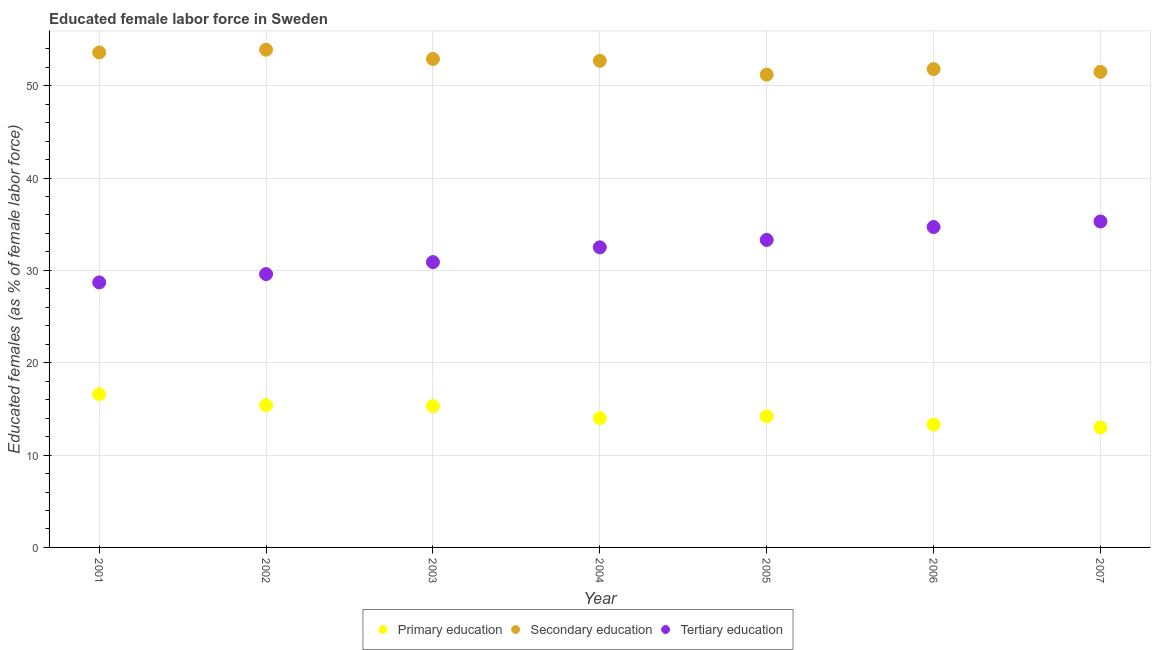How many different coloured dotlines are there?
Make the answer very short. 3. What is the percentage of female labor force who received primary education in 2001?
Your response must be concise. 16.6. Across all years, what is the maximum percentage of female labor force who received primary education?
Your response must be concise. 16.6. Across all years, what is the minimum percentage of female labor force who received secondary education?
Keep it short and to the point. 51.2. In which year was the percentage of female labor force who received tertiary education maximum?
Your answer should be compact. 2007. What is the total percentage of female labor force who received tertiary education in the graph?
Your answer should be very brief. 225. What is the difference between the percentage of female labor force who received secondary education in 2002 and that in 2005?
Give a very brief answer. 2.7. What is the difference between the percentage of female labor force who received tertiary education in 2006 and the percentage of female labor force who received primary education in 2004?
Your answer should be very brief. 20.7. What is the average percentage of female labor force who received secondary education per year?
Your answer should be very brief. 52.51. In the year 2007, what is the difference between the percentage of female labor force who received tertiary education and percentage of female labor force who received primary education?
Your answer should be very brief. 22.3. In how many years, is the percentage of female labor force who received primary education greater than 44 %?
Provide a succinct answer. 0. What is the ratio of the percentage of female labor force who received tertiary education in 2001 to that in 2004?
Ensure brevity in your answer.  0.88. What is the difference between the highest and the second highest percentage of female labor force who received secondary education?
Your answer should be compact. 0.3. What is the difference between the highest and the lowest percentage of female labor force who received secondary education?
Make the answer very short. 2.7. Is the sum of the percentage of female labor force who received primary education in 2002 and 2004 greater than the maximum percentage of female labor force who received secondary education across all years?
Your answer should be compact. No. Is the percentage of female labor force who received tertiary education strictly greater than the percentage of female labor force who received primary education over the years?
Give a very brief answer. Yes. How many dotlines are there?
Offer a terse response. 3. What is the difference between two consecutive major ticks on the Y-axis?
Your answer should be compact. 10. Does the graph contain any zero values?
Provide a short and direct response. No. Does the graph contain grids?
Give a very brief answer. Yes. Where does the legend appear in the graph?
Your answer should be very brief. Bottom center. What is the title of the graph?
Make the answer very short. Educated female labor force in Sweden. What is the label or title of the Y-axis?
Your response must be concise. Educated females (as % of female labor force). What is the Educated females (as % of female labor force) in Primary education in 2001?
Offer a very short reply. 16.6. What is the Educated females (as % of female labor force) of Secondary education in 2001?
Your answer should be compact. 53.6. What is the Educated females (as % of female labor force) in Tertiary education in 2001?
Give a very brief answer. 28.7. What is the Educated females (as % of female labor force) in Primary education in 2002?
Offer a very short reply. 15.4. What is the Educated females (as % of female labor force) of Secondary education in 2002?
Ensure brevity in your answer.  53.9. What is the Educated females (as % of female labor force) in Tertiary education in 2002?
Your response must be concise. 29.6. What is the Educated females (as % of female labor force) in Primary education in 2003?
Offer a very short reply. 15.3. What is the Educated females (as % of female labor force) in Secondary education in 2003?
Ensure brevity in your answer.  52.9. What is the Educated females (as % of female labor force) of Tertiary education in 2003?
Your answer should be very brief. 30.9. What is the Educated females (as % of female labor force) in Secondary education in 2004?
Keep it short and to the point. 52.7. What is the Educated females (as % of female labor force) in Tertiary education in 2004?
Ensure brevity in your answer.  32.5. What is the Educated females (as % of female labor force) of Primary education in 2005?
Your response must be concise. 14.2. What is the Educated females (as % of female labor force) of Secondary education in 2005?
Offer a very short reply. 51.2. What is the Educated females (as % of female labor force) in Tertiary education in 2005?
Ensure brevity in your answer.  33.3. What is the Educated females (as % of female labor force) in Primary education in 2006?
Make the answer very short. 13.3. What is the Educated females (as % of female labor force) in Secondary education in 2006?
Provide a succinct answer. 51.8. What is the Educated females (as % of female labor force) of Tertiary education in 2006?
Give a very brief answer. 34.7. What is the Educated females (as % of female labor force) of Primary education in 2007?
Keep it short and to the point. 13. What is the Educated females (as % of female labor force) in Secondary education in 2007?
Provide a succinct answer. 51.5. What is the Educated females (as % of female labor force) of Tertiary education in 2007?
Provide a succinct answer. 35.3. Across all years, what is the maximum Educated females (as % of female labor force) of Primary education?
Offer a very short reply. 16.6. Across all years, what is the maximum Educated females (as % of female labor force) in Secondary education?
Offer a terse response. 53.9. Across all years, what is the maximum Educated females (as % of female labor force) in Tertiary education?
Ensure brevity in your answer.  35.3. Across all years, what is the minimum Educated females (as % of female labor force) of Primary education?
Give a very brief answer. 13. Across all years, what is the minimum Educated females (as % of female labor force) in Secondary education?
Offer a terse response. 51.2. Across all years, what is the minimum Educated females (as % of female labor force) in Tertiary education?
Keep it short and to the point. 28.7. What is the total Educated females (as % of female labor force) in Primary education in the graph?
Offer a very short reply. 101.8. What is the total Educated females (as % of female labor force) in Secondary education in the graph?
Provide a short and direct response. 367.6. What is the total Educated females (as % of female labor force) of Tertiary education in the graph?
Your answer should be very brief. 225. What is the difference between the Educated females (as % of female labor force) in Primary education in 2001 and that in 2002?
Offer a very short reply. 1.2. What is the difference between the Educated females (as % of female labor force) of Tertiary education in 2001 and that in 2002?
Provide a succinct answer. -0.9. What is the difference between the Educated females (as % of female labor force) in Primary education in 2001 and that in 2003?
Offer a very short reply. 1.3. What is the difference between the Educated females (as % of female labor force) of Tertiary education in 2001 and that in 2003?
Keep it short and to the point. -2.2. What is the difference between the Educated females (as % of female labor force) of Primary education in 2001 and that in 2004?
Offer a terse response. 2.6. What is the difference between the Educated females (as % of female labor force) of Secondary education in 2001 and that in 2004?
Offer a very short reply. 0.9. What is the difference between the Educated females (as % of female labor force) in Tertiary education in 2001 and that in 2005?
Offer a very short reply. -4.6. What is the difference between the Educated females (as % of female labor force) of Primary education in 2001 and that in 2006?
Your response must be concise. 3.3. What is the difference between the Educated females (as % of female labor force) of Tertiary education in 2001 and that in 2007?
Your answer should be very brief. -6.6. What is the difference between the Educated females (as % of female labor force) of Primary education in 2002 and that in 2003?
Your answer should be very brief. 0.1. What is the difference between the Educated females (as % of female labor force) of Tertiary education in 2002 and that in 2003?
Provide a short and direct response. -1.3. What is the difference between the Educated females (as % of female labor force) in Primary education in 2002 and that in 2004?
Offer a terse response. 1.4. What is the difference between the Educated females (as % of female labor force) of Secondary education in 2002 and that in 2004?
Provide a short and direct response. 1.2. What is the difference between the Educated females (as % of female labor force) of Tertiary education in 2002 and that in 2004?
Your answer should be compact. -2.9. What is the difference between the Educated females (as % of female labor force) in Secondary education in 2002 and that in 2005?
Your answer should be compact. 2.7. What is the difference between the Educated females (as % of female labor force) of Tertiary education in 2002 and that in 2006?
Keep it short and to the point. -5.1. What is the difference between the Educated females (as % of female labor force) of Tertiary education in 2002 and that in 2007?
Provide a short and direct response. -5.7. What is the difference between the Educated females (as % of female labor force) of Primary education in 2003 and that in 2004?
Give a very brief answer. 1.3. What is the difference between the Educated females (as % of female labor force) of Secondary education in 2003 and that in 2004?
Keep it short and to the point. 0.2. What is the difference between the Educated females (as % of female labor force) of Tertiary education in 2003 and that in 2004?
Your answer should be very brief. -1.6. What is the difference between the Educated females (as % of female labor force) of Secondary education in 2003 and that in 2005?
Your response must be concise. 1.7. What is the difference between the Educated females (as % of female labor force) in Tertiary education in 2003 and that in 2005?
Offer a very short reply. -2.4. What is the difference between the Educated females (as % of female labor force) of Primary education in 2003 and that in 2006?
Your response must be concise. 2. What is the difference between the Educated females (as % of female labor force) in Secondary education in 2003 and that in 2006?
Give a very brief answer. 1.1. What is the difference between the Educated females (as % of female labor force) of Tertiary education in 2003 and that in 2006?
Keep it short and to the point. -3.8. What is the difference between the Educated females (as % of female labor force) of Tertiary education in 2004 and that in 2005?
Your answer should be very brief. -0.8. What is the difference between the Educated females (as % of female labor force) of Secondary education in 2004 and that in 2006?
Provide a succinct answer. 0.9. What is the difference between the Educated females (as % of female labor force) in Secondary education in 2004 and that in 2007?
Provide a succinct answer. 1.2. What is the difference between the Educated females (as % of female labor force) of Tertiary education in 2004 and that in 2007?
Provide a short and direct response. -2.8. What is the difference between the Educated females (as % of female labor force) of Primary education in 2005 and that in 2006?
Provide a succinct answer. 0.9. What is the difference between the Educated females (as % of female labor force) of Secondary education in 2005 and that in 2006?
Your answer should be compact. -0.6. What is the difference between the Educated females (as % of female labor force) of Primary education in 2005 and that in 2007?
Ensure brevity in your answer.  1.2. What is the difference between the Educated females (as % of female labor force) in Secondary education in 2005 and that in 2007?
Your answer should be compact. -0.3. What is the difference between the Educated females (as % of female labor force) of Tertiary education in 2005 and that in 2007?
Offer a very short reply. -2. What is the difference between the Educated females (as % of female labor force) in Primary education in 2001 and the Educated females (as % of female labor force) in Secondary education in 2002?
Offer a very short reply. -37.3. What is the difference between the Educated females (as % of female labor force) of Secondary education in 2001 and the Educated females (as % of female labor force) of Tertiary education in 2002?
Your answer should be very brief. 24. What is the difference between the Educated females (as % of female labor force) in Primary education in 2001 and the Educated females (as % of female labor force) in Secondary education in 2003?
Keep it short and to the point. -36.3. What is the difference between the Educated females (as % of female labor force) in Primary education in 2001 and the Educated females (as % of female labor force) in Tertiary education in 2003?
Offer a terse response. -14.3. What is the difference between the Educated females (as % of female labor force) in Secondary education in 2001 and the Educated females (as % of female labor force) in Tertiary education in 2003?
Offer a terse response. 22.7. What is the difference between the Educated females (as % of female labor force) of Primary education in 2001 and the Educated females (as % of female labor force) of Secondary education in 2004?
Offer a terse response. -36.1. What is the difference between the Educated females (as % of female labor force) in Primary education in 2001 and the Educated females (as % of female labor force) in Tertiary education in 2004?
Offer a terse response. -15.9. What is the difference between the Educated females (as % of female labor force) of Secondary education in 2001 and the Educated females (as % of female labor force) of Tertiary education in 2004?
Your answer should be compact. 21.1. What is the difference between the Educated females (as % of female labor force) of Primary education in 2001 and the Educated females (as % of female labor force) of Secondary education in 2005?
Your answer should be compact. -34.6. What is the difference between the Educated females (as % of female labor force) of Primary education in 2001 and the Educated females (as % of female labor force) of Tertiary education in 2005?
Your response must be concise. -16.7. What is the difference between the Educated females (as % of female labor force) in Secondary education in 2001 and the Educated females (as % of female labor force) in Tertiary education in 2005?
Give a very brief answer. 20.3. What is the difference between the Educated females (as % of female labor force) in Primary education in 2001 and the Educated females (as % of female labor force) in Secondary education in 2006?
Provide a short and direct response. -35.2. What is the difference between the Educated females (as % of female labor force) in Primary education in 2001 and the Educated females (as % of female labor force) in Tertiary education in 2006?
Your answer should be compact. -18.1. What is the difference between the Educated females (as % of female labor force) in Secondary education in 2001 and the Educated females (as % of female labor force) in Tertiary education in 2006?
Keep it short and to the point. 18.9. What is the difference between the Educated females (as % of female labor force) in Primary education in 2001 and the Educated females (as % of female labor force) in Secondary education in 2007?
Make the answer very short. -34.9. What is the difference between the Educated females (as % of female labor force) of Primary education in 2001 and the Educated females (as % of female labor force) of Tertiary education in 2007?
Ensure brevity in your answer.  -18.7. What is the difference between the Educated females (as % of female labor force) in Primary education in 2002 and the Educated females (as % of female labor force) in Secondary education in 2003?
Make the answer very short. -37.5. What is the difference between the Educated females (as % of female labor force) in Primary education in 2002 and the Educated females (as % of female labor force) in Tertiary education in 2003?
Keep it short and to the point. -15.5. What is the difference between the Educated females (as % of female labor force) of Primary education in 2002 and the Educated females (as % of female labor force) of Secondary education in 2004?
Offer a very short reply. -37.3. What is the difference between the Educated females (as % of female labor force) in Primary education in 2002 and the Educated females (as % of female labor force) in Tertiary education in 2004?
Provide a short and direct response. -17.1. What is the difference between the Educated females (as % of female labor force) of Secondary education in 2002 and the Educated females (as % of female labor force) of Tertiary education in 2004?
Make the answer very short. 21.4. What is the difference between the Educated females (as % of female labor force) in Primary education in 2002 and the Educated females (as % of female labor force) in Secondary education in 2005?
Make the answer very short. -35.8. What is the difference between the Educated females (as % of female labor force) of Primary education in 2002 and the Educated females (as % of female labor force) of Tertiary education in 2005?
Offer a very short reply. -17.9. What is the difference between the Educated females (as % of female labor force) in Secondary education in 2002 and the Educated females (as % of female labor force) in Tertiary education in 2005?
Provide a short and direct response. 20.6. What is the difference between the Educated females (as % of female labor force) in Primary education in 2002 and the Educated females (as % of female labor force) in Secondary education in 2006?
Your answer should be compact. -36.4. What is the difference between the Educated females (as % of female labor force) in Primary education in 2002 and the Educated females (as % of female labor force) in Tertiary education in 2006?
Your response must be concise. -19.3. What is the difference between the Educated females (as % of female labor force) in Secondary education in 2002 and the Educated females (as % of female labor force) in Tertiary education in 2006?
Provide a short and direct response. 19.2. What is the difference between the Educated females (as % of female labor force) in Primary education in 2002 and the Educated females (as % of female labor force) in Secondary education in 2007?
Ensure brevity in your answer.  -36.1. What is the difference between the Educated females (as % of female labor force) in Primary education in 2002 and the Educated females (as % of female labor force) in Tertiary education in 2007?
Your answer should be compact. -19.9. What is the difference between the Educated females (as % of female labor force) in Primary education in 2003 and the Educated females (as % of female labor force) in Secondary education in 2004?
Give a very brief answer. -37.4. What is the difference between the Educated females (as % of female labor force) in Primary education in 2003 and the Educated females (as % of female labor force) in Tertiary education in 2004?
Offer a terse response. -17.2. What is the difference between the Educated females (as % of female labor force) of Secondary education in 2003 and the Educated females (as % of female labor force) of Tertiary education in 2004?
Provide a succinct answer. 20.4. What is the difference between the Educated females (as % of female labor force) in Primary education in 2003 and the Educated females (as % of female labor force) in Secondary education in 2005?
Ensure brevity in your answer.  -35.9. What is the difference between the Educated females (as % of female labor force) in Primary education in 2003 and the Educated females (as % of female labor force) in Tertiary education in 2005?
Provide a short and direct response. -18. What is the difference between the Educated females (as % of female labor force) in Secondary education in 2003 and the Educated females (as % of female labor force) in Tertiary education in 2005?
Your response must be concise. 19.6. What is the difference between the Educated females (as % of female labor force) of Primary education in 2003 and the Educated females (as % of female labor force) of Secondary education in 2006?
Your answer should be compact. -36.5. What is the difference between the Educated females (as % of female labor force) in Primary education in 2003 and the Educated females (as % of female labor force) in Tertiary education in 2006?
Keep it short and to the point. -19.4. What is the difference between the Educated females (as % of female labor force) of Secondary education in 2003 and the Educated females (as % of female labor force) of Tertiary education in 2006?
Provide a short and direct response. 18.2. What is the difference between the Educated females (as % of female labor force) of Primary education in 2003 and the Educated females (as % of female labor force) of Secondary education in 2007?
Offer a very short reply. -36.2. What is the difference between the Educated females (as % of female labor force) of Primary education in 2003 and the Educated females (as % of female labor force) of Tertiary education in 2007?
Offer a terse response. -20. What is the difference between the Educated females (as % of female labor force) of Primary education in 2004 and the Educated females (as % of female labor force) of Secondary education in 2005?
Your response must be concise. -37.2. What is the difference between the Educated females (as % of female labor force) of Primary education in 2004 and the Educated females (as % of female labor force) of Tertiary education in 2005?
Your answer should be very brief. -19.3. What is the difference between the Educated females (as % of female labor force) of Primary education in 2004 and the Educated females (as % of female labor force) of Secondary education in 2006?
Provide a succinct answer. -37.8. What is the difference between the Educated females (as % of female labor force) in Primary education in 2004 and the Educated females (as % of female labor force) in Tertiary education in 2006?
Your answer should be compact. -20.7. What is the difference between the Educated females (as % of female labor force) of Secondary education in 2004 and the Educated females (as % of female labor force) of Tertiary education in 2006?
Keep it short and to the point. 18. What is the difference between the Educated females (as % of female labor force) of Primary education in 2004 and the Educated females (as % of female labor force) of Secondary education in 2007?
Provide a short and direct response. -37.5. What is the difference between the Educated females (as % of female labor force) of Primary education in 2004 and the Educated females (as % of female labor force) of Tertiary education in 2007?
Your response must be concise. -21.3. What is the difference between the Educated females (as % of female labor force) of Secondary education in 2004 and the Educated females (as % of female labor force) of Tertiary education in 2007?
Make the answer very short. 17.4. What is the difference between the Educated females (as % of female labor force) of Primary education in 2005 and the Educated females (as % of female labor force) of Secondary education in 2006?
Give a very brief answer. -37.6. What is the difference between the Educated females (as % of female labor force) of Primary education in 2005 and the Educated females (as % of female labor force) of Tertiary education in 2006?
Make the answer very short. -20.5. What is the difference between the Educated females (as % of female labor force) of Primary education in 2005 and the Educated females (as % of female labor force) of Secondary education in 2007?
Provide a short and direct response. -37.3. What is the difference between the Educated females (as % of female labor force) in Primary education in 2005 and the Educated females (as % of female labor force) in Tertiary education in 2007?
Keep it short and to the point. -21.1. What is the difference between the Educated females (as % of female labor force) in Secondary education in 2005 and the Educated females (as % of female labor force) in Tertiary education in 2007?
Your answer should be compact. 15.9. What is the difference between the Educated females (as % of female labor force) in Primary education in 2006 and the Educated females (as % of female labor force) in Secondary education in 2007?
Make the answer very short. -38.2. What is the average Educated females (as % of female labor force) of Primary education per year?
Your answer should be very brief. 14.54. What is the average Educated females (as % of female labor force) of Secondary education per year?
Provide a succinct answer. 52.51. What is the average Educated females (as % of female labor force) in Tertiary education per year?
Offer a terse response. 32.14. In the year 2001, what is the difference between the Educated females (as % of female labor force) of Primary education and Educated females (as % of female labor force) of Secondary education?
Keep it short and to the point. -37. In the year 2001, what is the difference between the Educated females (as % of female labor force) in Secondary education and Educated females (as % of female labor force) in Tertiary education?
Provide a succinct answer. 24.9. In the year 2002, what is the difference between the Educated females (as % of female labor force) of Primary education and Educated females (as % of female labor force) of Secondary education?
Offer a very short reply. -38.5. In the year 2002, what is the difference between the Educated females (as % of female labor force) of Secondary education and Educated females (as % of female labor force) of Tertiary education?
Provide a succinct answer. 24.3. In the year 2003, what is the difference between the Educated females (as % of female labor force) in Primary education and Educated females (as % of female labor force) in Secondary education?
Your answer should be compact. -37.6. In the year 2003, what is the difference between the Educated females (as % of female labor force) in Primary education and Educated females (as % of female labor force) in Tertiary education?
Make the answer very short. -15.6. In the year 2004, what is the difference between the Educated females (as % of female labor force) of Primary education and Educated females (as % of female labor force) of Secondary education?
Offer a terse response. -38.7. In the year 2004, what is the difference between the Educated females (as % of female labor force) in Primary education and Educated females (as % of female labor force) in Tertiary education?
Make the answer very short. -18.5. In the year 2004, what is the difference between the Educated females (as % of female labor force) in Secondary education and Educated females (as % of female labor force) in Tertiary education?
Make the answer very short. 20.2. In the year 2005, what is the difference between the Educated females (as % of female labor force) in Primary education and Educated females (as % of female labor force) in Secondary education?
Give a very brief answer. -37. In the year 2005, what is the difference between the Educated females (as % of female labor force) in Primary education and Educated females (as % of female labor force) in Tertiary education?
Make the answer very short. -19.1. In the year 2005, what is the difference between the Educated females (as % of female labor force) in Secondary education and Educated females (as % of female labor force) in Tertiary education?
Ensure brevity in your answer.  17.9. In the year 2006, what is the difference between the Educated females (as % of female labor force) of Primary education and Educated females (as % of female labor force) of Secondary education?
Give a very brief answer. -38.5. In the year 2006, what is the difference between the Educated females (as % of female labor force) of Primary education and Educated females (as % of female labor force) of Tertiary education?
Make the answer very short. -21.4. In the year 2006, what is the difference between the Educated females (as % of female labor force) in Secondary education and Educated females (as % of female labor force) in Tertiary education?
Provide a succinct answer. 17.1. In the year 2007, what is the difference between the Educated females (as % of female labor force) of Primary education and Educated females (as % of female labor force) of Secondary education?
Ensure brevity in your answer.  -38.5. In the year 2007, what is the difference between the Educated females (as % of female labor force) of Primary education and Educated females (as % of female labor force) of Tertiary education?
Offer a terse response. -22.3. What is the ratio of the Educated females (as % of female labor force) of Primary education in 2001 to that in 2002?
Give a very brief answer. 1.08. What is the ratio of the Educated females (as % of female labor force) of Tertiary education in 2001 to that in 2002?
Offer a very short reply. 0.97. What is the ratio of the Educated females (as % of female labor force) of Primary education in 2001 to that in 2003?
Make the answer very short. 1.08. What is the ratio of the Educated females (as % of female labor force) of Secondary education in 2001 to that in 2003?
Give a very brief answer. 1.01. What is the ratio of the Educated females (as % of female labor force) in Tertiary education in 2001 to that in 2003?
Your answer should be compact. 0.93. What is the ratio of the Educated females (as % of female labor force) in Primary education in 2001 to that in 2004?
Your response must be concise. 1.19. What is the ratio of the Educated females (as % of female labor force) of Secondary education in 2001 to that in 2004?
Your answer should be very brief. 1.02. What is the ratio of the Educated females (as % of female labor force) of Tertiary education in 2001 to that in 2004?
Make the answer very short. 0.88. What is the ratio of the Educated females (as % of female labor force) in Primary education in 2001 to that in 2005?
Offer a very short reply. 1.17. What is the ratio of the Educated females (as % of female labor force) of Secondary education in 2001 to that in 2005?
Your response must be concise. 1.05. What is the ratio of the Educated females (as % of female labor force) in Tertiary education in 2001 to that in 2005?
Offer a terse response. 0.86. What is the ratio of the Educated females (as % of female labor force) of Primary education in 2001 to that in 2006?
Provide a succinct answer. 1.25. What is the ratio of the Educated females (as % of female labor force) of Secondary education in 2001 to that in 2006?
Keep it short and to the point. 1.03. What is the ratio of the Educated females (as % of female labor force) of Tertiary education in 2001 to that in 2006?
Your answer should be compact. 0.83. What is the ratio of the Educated females (as % of female labor force) of Primary education in 2001 to that in 2007?
Provide a short and direct response. 1.28. What is the ratio of the Educated females (as % of female labor force) in Secondary education in 2001 to that in 2007?
Keep it short and to the point. 1.04. What is the ratio of the Educated females (as % of female labor force) in Tertiary education in 2001 to that in 2007?
Keep it short and to the point. 0.81. What is the ratio of the Educated females (as % of female labor force) in Primary education in 2002 to that in 2003?
Offer a terse response. 1.01. What is the ratio of the Educated females (as % of female labor force) of Secondary education in 2002 to that in 2003?
Your answer should be very brief. 1.02. What is the ratio of the Educated females (as % of female labor force) in Tertiary education in 2002 to that in 2003?
Offer a very short reply. 0.96. What is the ratio of the Educated females (as % of female labor force) of Secondary education in 2002 to that in 2004?
Your response must be concise. 1.02. What is the ratio of the Educated females (as % of female labor force) of Tertiary education in 2002 to that in 2004?
Make the answer very short. 0.91. What is the ratio of the Educated females (as % of female labor force) of Primary education in 2002 to that in 2005?
Give a very brief answer. 1.08. What is the ratio of the Educated females (as % of female labor force) of Secondary education in 2002 to that in 2005?
Provide a short and direct response. 1.05. What is the ratio of the Educated females (as % of female labor force) of Primary education in 2002 to that in 2006?
Offer a terse response. 1.16. What is the ratio of the Educated females (as % of female labor force) in Secondary education in 2002 to that in 2006?
Offer a terse response. 1.04. What is the ratio of the Educated females (as % of female labor force) in Tertiary education in 2002 to that in 2006?
Provide a short and direct response. 0.85. What is the ratio of the Educated females (as % of female labor force) of Primary education in 2002 to that in 2007?
Keep it short and to the point. 1.18. What is the ratio of the Educated females (as % of female labor force) in Secondary education in 2002 to that in 2007?
Your answer should be compact. 1.05. What is the ratio of the Educated females (as % of female labor force) in Tertiary education in 2002 to that in 2007?
Offer a terse response. 0.84. What is the ratio of the Educated females (as % of female labor force) of Primary education in 2003 to that in 2004?
Give a very brief answer. 1.09. What is the ratio of the Educated females (as % of female labor force) of Secondary education in 2003 to that in 2004?
Your response must be concise. 1. What is the ratio of the Educated females (as % of female labor force) of Tertiary education in 2003 to that in 2004?
Your answer should be very brief. 0.95. What is the ratio of the Educated females (as % of female labor force) of Primary education in 2003 to that in 2005?
Your answer should be very brief. 1.08. What is the ratio of the Educated females (as % of female labor force) of Secondary education in 2003 to that in 2005?
Your answer should be compact. 1.03. What is the ratio of the Educated females (as % of female labor force) of Tertiary education in 2003 to that in 2005?
Offer a terse response. 0.93. What is the ratio of the Educated females (as % of female labor force) of Primary education in 2003 to that in 2006?
Your response must be concise. 1.15. What is the ratio of the Educated females (as % of female labor force) in Secondary education in 2003 to that in 2006?
Provide a short and direct response. 1.02. What is the ratio of the Educated females (as % of female labor force) in Tertiary education in 2003 to that in 2006?
Your answer should be compact. 0.89. What is the ratio of the Educated females (as % of female labor force) of Primary education in 2003 to that in 2007?
Provide a short and direct response. 1.18. What is the ratio of the Educated females (as % of female labor force) of Secondary education in 2003 to that in 2007?
Provide a succinct answer. 1.03. What is the ratio of the Educated females (as % of female labor force) in Tertiary education in 2003 to that in 2007?
Provide a short and direct response. 0.88. What is the ratio of the Educated females (as % of female labor force) of Primary education in 2004 to that in 2005?
Make the answer very short. 0.99. What is the ratio of the Educated females (as % of female labor force) in Secondary education in 2004 to that in 2005?
Give a very brief answer. 1.03. What is the ratio of the Educated females (as % of female labor force) of Tertiary education in 2004 to that in 2005?
Keep it short and to the point. 0.98. What is the ratio of the Educated females (as % of female labor force) of Primary education in 2004 to that in 2006?
Your response must be concise. 1.05. What is the ratio of the Educated females (as % of female labor force) in Secondary education in 2004 to that in 2006?
Provide a short and direct response. 1.02. What is the ratio of the Educated females (as % of female labor force) in Tertiary education in 2004 to that in 2006?
Your answer should be compact. 0.94. What is the ratio of the Educated females (as % of female labor force) in Primary education in 2004 to that in 2007?
Your answer should be very brief. 1.08. What is the ratio of the Educated females (as % of female labor force) of Secondary education in 2004 to that in 2007?
Your answer should be compact. 1.02. What is the ratio of the Educated females (as % of female labor force) in Tertiary education in 2004 to that in 2007?
Make the answer very short. 0.92. What is the ratio of the Educated females (as % of female labor force) of Primary education in 2005 to that in 2006?
Your answer should be compact. 1.07. What is the ratio of the Educated females (as % of female labor force) of Secondary education in 2005 to that in 2006?
Provide a succinct answer. 0.99. What is the ratio of the Educated females (as % of female labor force) of Tertiary education in 2005 to that in 2006?
Ensure brevity in your answer.  0.96. What is the ratio of the Educated females (as % of female labor force) in Primary education in 2005 to that in 2007?
Your answer should be compact. 1.09. What is the ratio of the Educated females (as % of female labor force) of Secondary education in 2005 to that in 2007?
Your answer should be compact. 0.99. What is the ratio of the Educated females (as % of female labor force) in Tertiary education in 2005 to that in 2007?
Offer a terse response. 0.94. What is the ratio of the Educated females (as % of female labor force) of Primary education in 2006 to that in 2007?
Offer a very short reply. 1.02. What is the ratio of the Educated females (as % of female labor force) in Secondary education in 2006 to that in 2007?
Your response must be concise. 1.01. What is the difference between the highest and the lowest Educated females (as % of female labor force) of Secondary education?
Your answer should be compact. 2.7. 